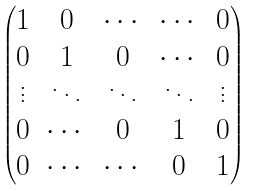<formula> <loc_0><loc_0><loc_500><loc_500>\begin{pmatrix} 1 & 0 & \cdots & \cdots & 0 \\ 0 & 1 & 0 & \cdots & 0 \\ \vdots & \ddots & \ddots & \ddots & \vdots \\ 0 & \cdots & 0 & 1 & 0 \\ 0 & \cdots & \cdots & 0 & 1 \end{pmatrix}</formula> 